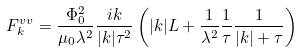Convert formula to latex. <formula><loc_0><loc_0><loc_500><loc_500>F ^ { v v } _ { k } = \frac { \Phi _ { 0 } ^ { 2 } } { \mu _ { 0 } \lambda ^ { 2 } } \frac { i k } { | k | \tau ^ { 2 } } \left ( | k | L + \frac { 1 } { \lambda ^ { 2 } } \frac { 1 } { \tau } \frac { 1 } { | k | + \tau } \right )</formula> 